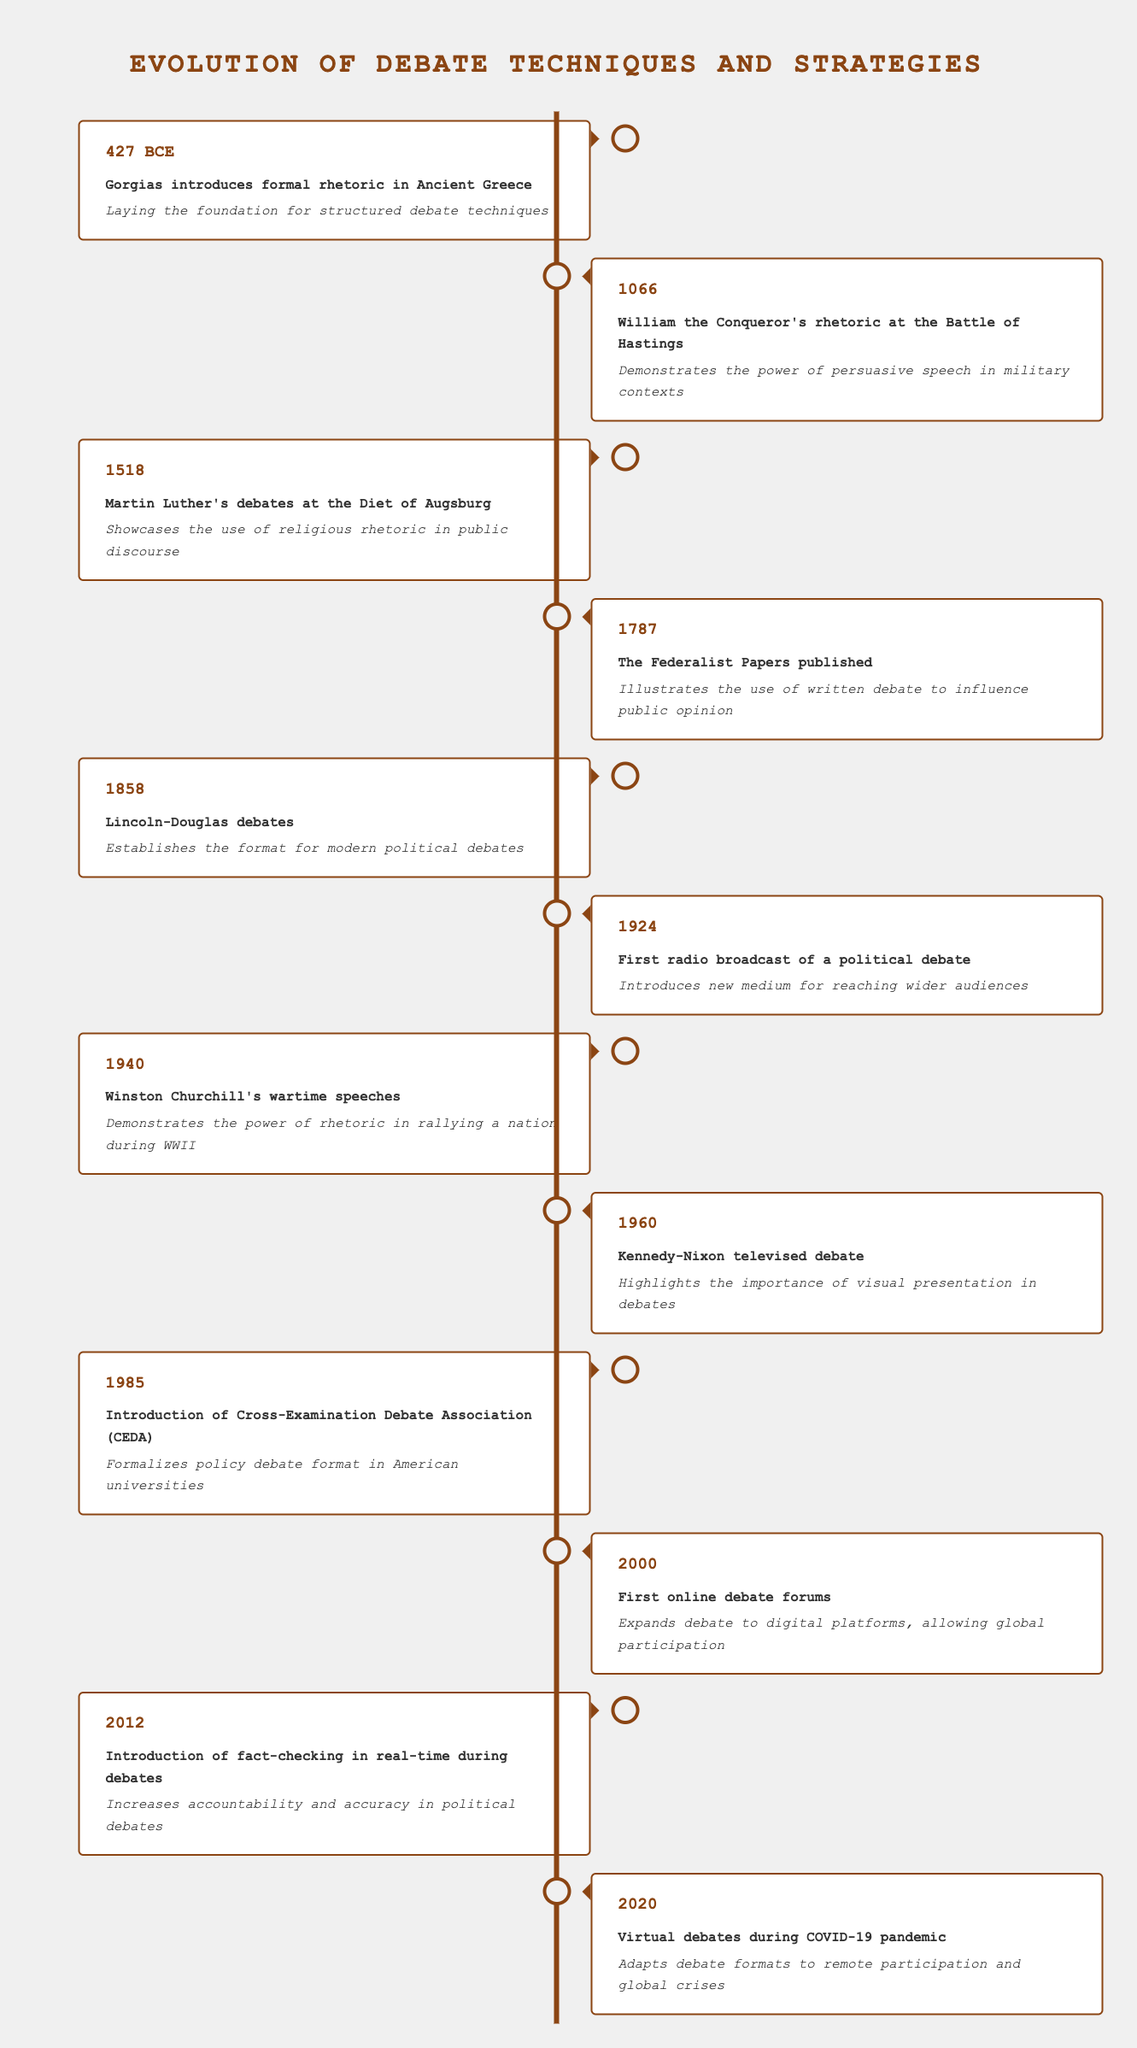What year did Gorgias introduce formal rhetoric? The table lists the year 427 alongside the event Gorgias introducing formal rhetoric in Ancient Greece. Therefore, the answer can be directly retrieved from this row.
Answer: 427 Which event occurred first, the publication of The Federalist Papers or the Lincoln-Douglas debates? By comparing the years associated with each event, The Federalist Papers published in 1787 and the Lincoln-Douglas debates in 1858, we can see that 1787 is earlier than 1858. Thus, the publication of The Federalist Papers occurred first.
Answer: The Federalist Papers True or False: The first radio broadcast of a political debate occurred in 1940. The table states that the first radio broadcast of a political debate occurred in 1924, while the year 1940 is associated with Winston Churchill's wartime speeches. Therefore, the statement is false.
Answer: False What is the average year of the events that took place in the 20th century? The events in the 20th century listed in the table are from 1924, 1940, 1960, 1985, 2000, 2012, and 2020. To find the average, we sum these years: (1924 + 1940 + 1960 + 1985 + 2000 + 2012 + 2020) = 13941. There are 7 events, so we divide 13941 by 7, resulting in an average year of approximately 1991.57, which rounds to 1992.
Answer: 1992 Which event highlights the importance of visual presentation in debates, and what year did it occur? The event listed in the table that emphasizes visual presentation is the Kennedy-Nixon televised debate, which occurred in 1960. This can be confirmed from the respective entry in the timeline.
Answer: Kennedy-Nixon televised debate, 1960 